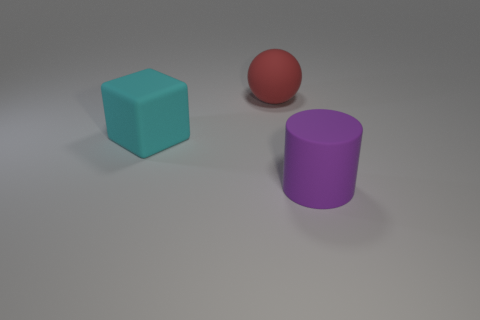Add 1 big green cylinders. How many objects exist? 4 Subtract all balls. How many objects are left? 2 Add 1 red cubes. How many red cubes exist? 1 Subtract 0 blue blocks. How many objects are left? 3 Subtract all red metallic cubes. Subtract all big cyan matte objects. How many objects are left? 2 Add 2 spheres. How many spheres are left? 3 